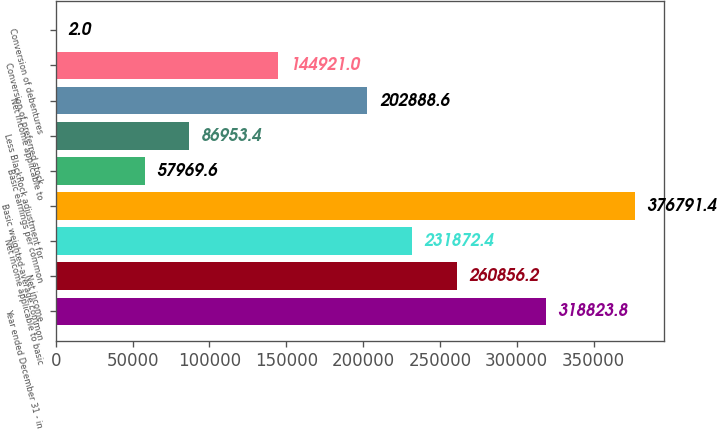<chart> <loc_0><loc_0><loc_500><loc_500><bar_chart><fcel>Year ended December 31 - in<fcel>Net income<fcel>Net income applicable to basic<fcel>Basic weighted-average common<fcel>Basic earnings per common<fcel>Less BlackRock adjustment for<fcel>Net income applicable to<fcel>Conversion of preferred stock<fcel>Conversion of debentures<nl><fcel>318824<fcel>260856<fcel>231872<fcel>376791<fcel>57969.6<fcel>86953.4<fcel>202889<fcel>144921<fcel>2<nl></chart> 